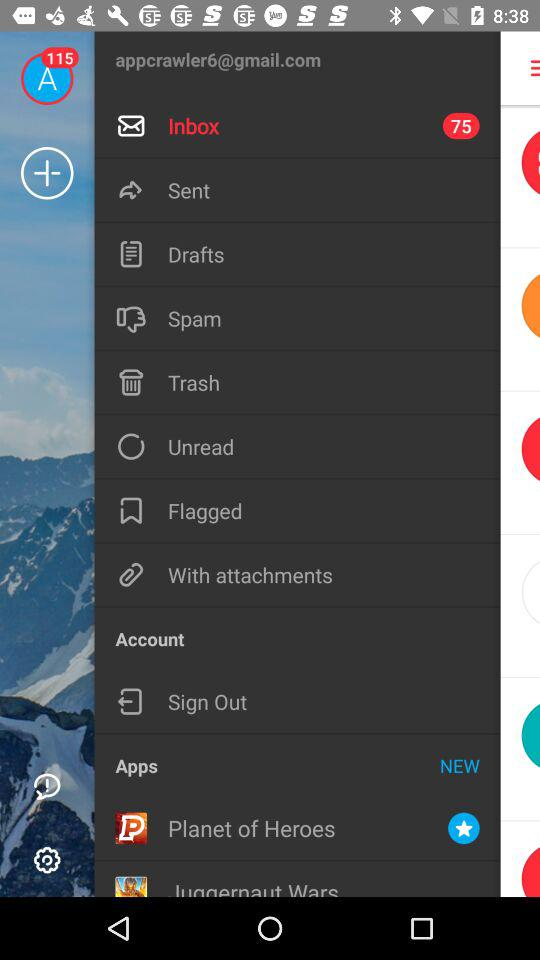How many notifications are there for the inbox? There are 75 notifications. 